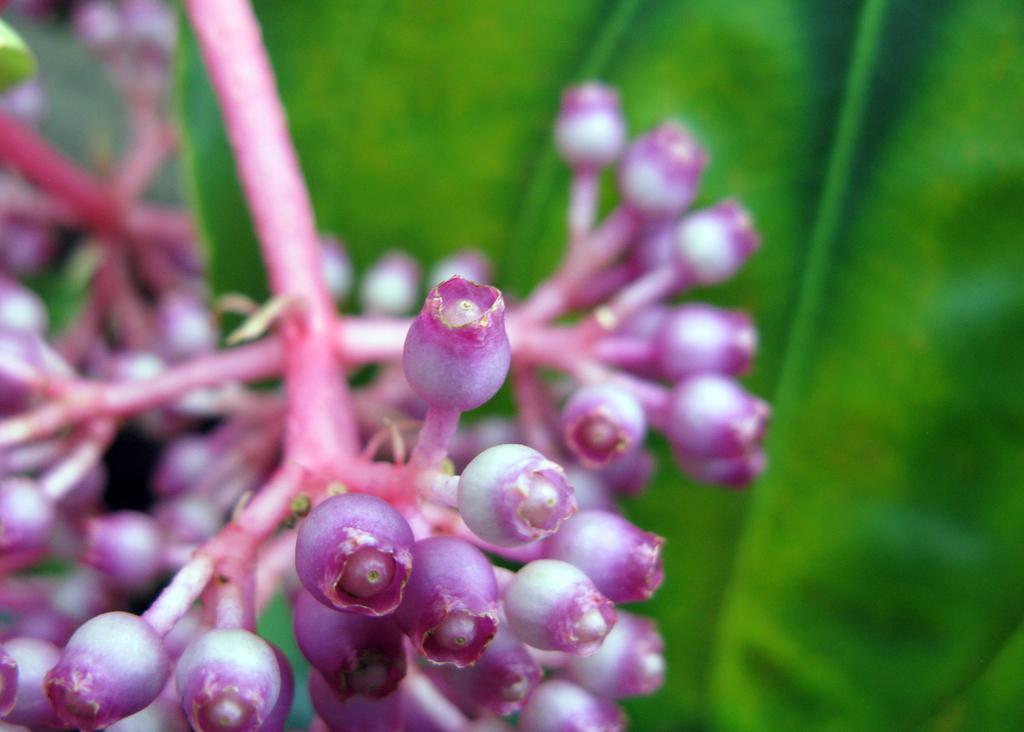Please provide a concise description of this image. In this picture we can see some buds and leaves to the trees. 